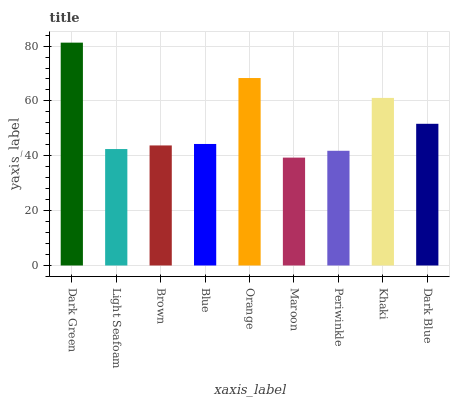Is Maroon the minimum?
Answer yes or no. Yes. Is Dark Green the maximum?
Answer yes or no. Yes. Is Light Seafoam the minimum?
Answer yes or no. No. Is Light Seafoam the maximum?
Answer yes or no. No. Is Dark Green greater than Light Seafoam?
Answer yes or no. Yes. Is Light Seafoam less than Dark Green?
Answer yes or no. Yes. Is Light Seafoam greater than Dark Green?
Answer yes or no. No. Is Dark Green less than Light Seafoam?
Answer yes or no. No. Is Blue the high median?
Answer yes or no. Yes. Is Blue the low median?
Answer yes or no. Yes. Is Khaki the high median?
Answer yes or no. No. Is Dark Green the low median?
Answer yes or no. No. 